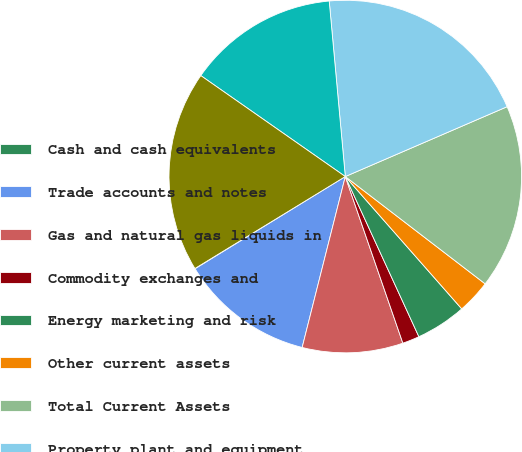Convert chart. <chart><loc_0><loc_0><loc_500><loc_500><pie_chart><fcel>Cash and cash equivalents<fcel>Trade accounts and notes<fcel>Gas and natural gas liquids in<fcel>Commodity exchanges and<fcel>Energy marketing and risk<fcel>Other current assets<fcel>Total Current Assets<fcel>Property plant and equipment<fcel>Accumulated depreciation and<fcel>Net Property Plant and<nl><fcel>0.03%<fcel>12.3%<fcel>9.23%<fcel>1.56%<fcel>4.63%<fcel>3.1%<fcel>16.9%<fcel>19.97%<fcel>13.84%<fcel>18.44%<nl></chart> 